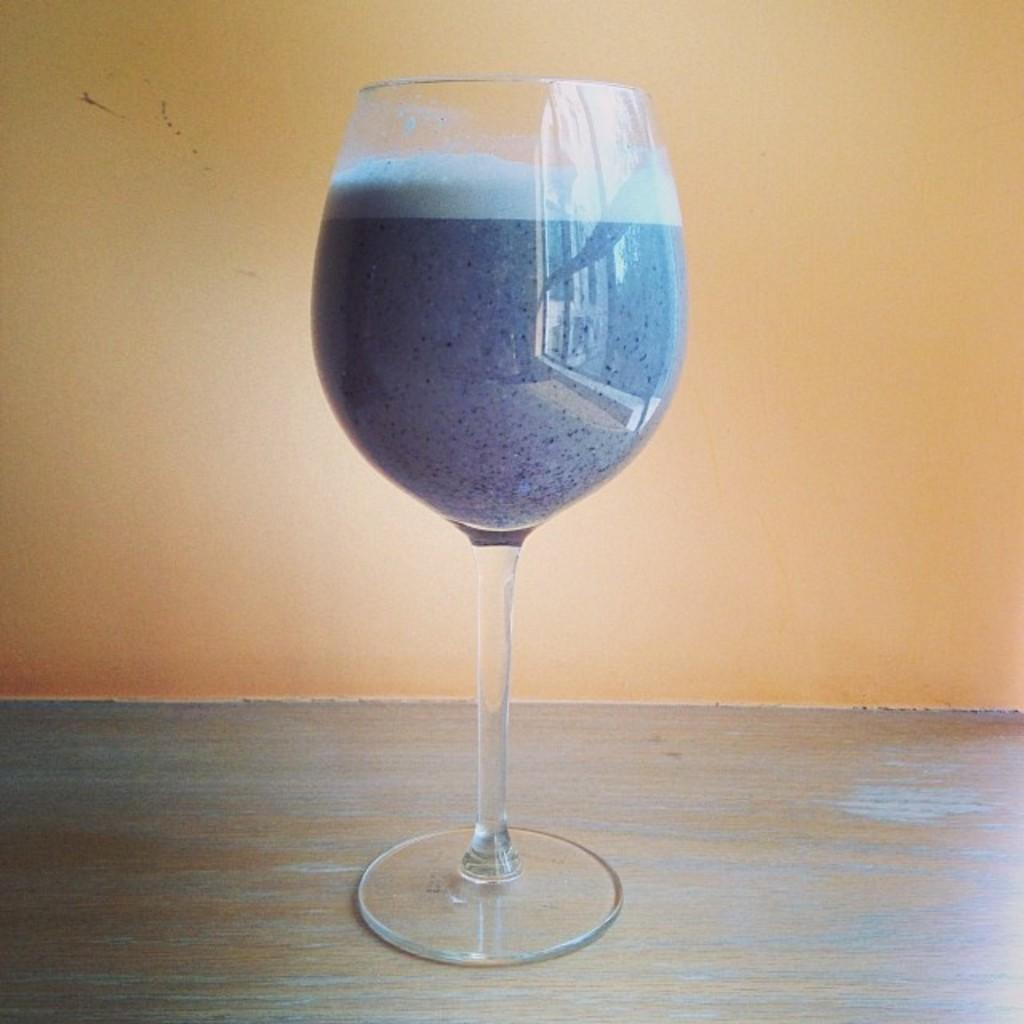What object is present in the image that can hold a liquid? There is a glass in the image. What liquid is contained within the glass? The glass contains juice. What type of spy is depicted in the image? There is no spy present in the image; it only features a glass containing juice. 